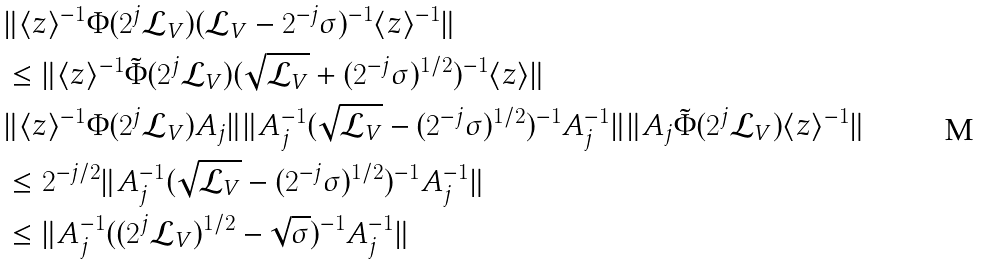Convert formula to latex. <formula><loc_0><loc_0><loc_500><loc_500>& \| \langle z \rangle ^ { - 1 } \Phi ( 2 ^ { j } \mathcal { L } _ { V } ) ( \mathcal { L } _ { V } - 2 ^ { - j } \sigma ) ^ { - 1 } \langle z \rangle ^ { - 1 } \| \\ & \leq \| \langle z \rangle ^ { - 1 } \tilde { \Phi } ( 2 ^ { j } \mathcal { L } _ { V } ) ( \sqrt { \mathcal { L } _ { V } } + ( 2 ^ { - j } \sigma ) ^ { 1 / 2 } ) ^ { - 1 } \langle z \rangle \| \\ & \| \langle z \rangle ^ { - 1 } \Phi ( 2 ^ { j } \mathcal { L } _ { V } ) A _ { j } \| \| A _ { j } ^ { - 1 } ( \sqrt { \mathcal { L } _ { V } } - ( 2 ^ { - j } \sigma ) ^ { 1 / 2 } ) ^ { - 1 } A _ { j } ^ { - 1 } \| \| A _ { j } \tilde { \Phi } ( 2 ^ { j } \mathcal { L } _ { V } ) \langle z \rangle ^ { - 1 } \| \\ & \leq 2 ^ { - j / 2 } \| A _ { j } ^ { - 1 } ( \sqrt { \mathcal { L } _ { V } } - ( 2 ^ { - j } \sigma ) ^ { 1 / 2 } ) ^ { - 1 } A _ { j } ^ { - 1 } \| \\ & \leq \| A _ { j } ^ { - 1 } ( ( 2 ^ { j } \mathcal { L } _ { V } ) ^ { 1 / 2 } - \sqrt { \sigma } ) ^ { - 1 } A _ { j } ^ { - 1 } \|</formula> 